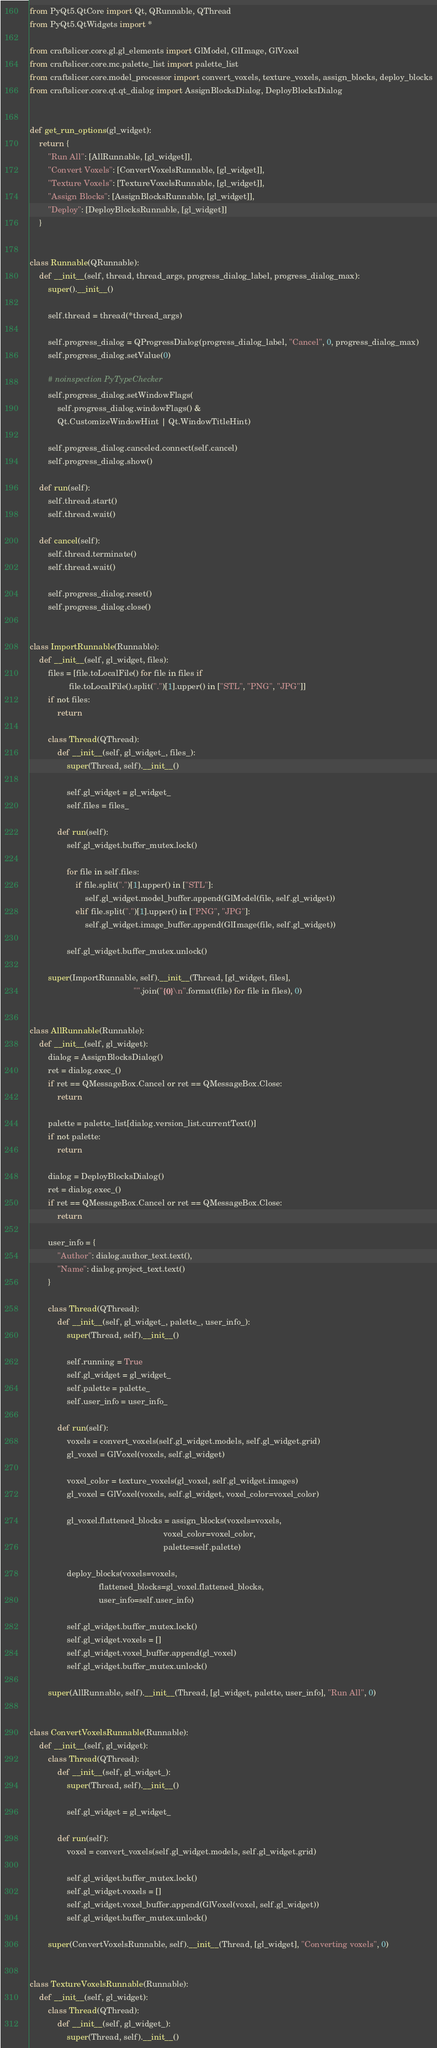<code> <loc_0><loc_0><loc_500><loc_500><_Python_>from PyQt5.QtCore import Qt, QRunnable, QThread
from PyQt5.QtWidgets import *

from craftslicer.core.gl.gl_elements import GlModel, GlImage, GlVoxel
from craftslicer.core.mc.palette_list import palette_list
from craftslicer.core.model_processor import convert_voxels, texture_voxels, assign_blocks, deploy_blocks
from craftslicer.core.qt.qt_dialog import AssignBlocksDialog, DeployBlocksDialog


def get_run_options(gl_widget):
    return {
        "Run All": [AllRunnable, [gl_widget]],
        "Convert Voxels": [ConvertVoxelsRunnable, [gl_widget]],
        "Texture Voxels": [TextureVoxelsRunnable, [gl_widget]],
        "Assign Blocks": [AssignBlocksRunnable, [gl_widget]],
        "Deploy": [DeployBlocksRunnable, [gl_widget]]
    }


class Runnable(QRunnable):
    def __init__(self, thread, thread_args, progress_dialog_label, progress_dialog_max):
        super().__init__()

        self.thread = thread(*thread_args)

        self.progress_dialog = QProgressDialog(progress_dialog_label, "Cancel", 0, progress_dialog_max)
        self.progress_dialog.setValue(0)

        # noinspection PyTypeChecker
        self.progress_dialog.setWindowFlags(
            self.progress_dialog.windowFlags() &
            Qt.CustomizeWindowHint | Qt.WindowTitleHint)

        self.progress_dialog.canceled.connect(self.cancel)
        self.progress_dialog.show()

    def run(self):
        self.thread.start()
        self.thread.wait()

    def cancel(self):
        self.thread.terminate()
        self.thread.wait()

        self.progress_dialog.reset()
        self.progress_dialog.close()


class ImportRunnable(Runnable):
    def __init__(self, gl_widget, files):
        files = [file.toLocalFile() for file in files if
                 file.toLocalFile().split(".")[1].upper() in ["STL", "PNG", "JPG"]]
        if not files:
            return

        class Thread(QThread):
            def __init__(self, gl_widget_, files_):
                super(Thread, self).__init__()

                self.gl_widget = gl_widget_
                self.files = files_

            def run(self):
                self.gl_widget.buffer_mutex.lock()

                for file in self.files:
                    if file.split(".")[1].upper() in ["STL"]:
                        self.gl_widget.model_buffer.append(GlModel(file, self.gl_widget))
                    elif file.split(".")[1].upper() in ["PNG", "JPG"]:
                        self.gl_widget.image_buffer.append(GlImage(file, self.gl_widget))

                self.gl_widget.buffer_mutex.unlock()

        super(ImportRunnable, self).__init__(Thread, [gl_widget, files],
                                             "".join("{0}\n".format(file) for file in files), 0)


class AllRunnable(Runnable):
    def __init__(self, gl_widget):
        dialog = AssignBlocksDialog()
        ret = dialog.exec_()
        if ret == QMessageBox.Cancel or ret == QMessageBox.Close:
            return

        palette = palette_list[dialog.version_list.currentText()]
        if not palette:
            return

        dialog = DeployBlocksDialog()
        ret = dialog.exec_()
        if ret == QMessageBox.Cancel or ret == QMessageBox.Close:
            return

        user_info = {
            "Author": dialog.author_text.text(),
            "Name": dialog.project_text.text()
        }

        class Thread(QThread):
            def __init__(self, gl_widget_, palette_, user_info_):
                super(Thread, self).__init__()

                self.running = True
                self.gl_widget = gl_widget_
                self.palette = palette_
                self.user_info = user_info_

            def run(self):
                voxels = convert_voxels(self.gl_widget.models, self.gl_widget.grid)
                gl_voxel = GlVoxel(voxels, self.gl_widget)

                voxel_color = texture_voxels(gl_voxel, self.gl_widget.images)
                gl_voxel = GlVoxel(voxels, self.gl_widget, voxel_color=voxel_color)

                gl_voxel.flattened_blocks = assign_blocks(voxels=voxels,
                                                          voxel_color=voxel_color,
                                                          palette=self.palette)

                deploy_blocks(voxels=voxels,
                              flattened_blocks=gl_voxel.flattened_blocks,
                              user_info=self.user_info)

                self.gl_widget.buffer_mutex.lock()
                self.gl_widget.voxels = []
                self.gl_widget.voxel_buffer.append(gl_voxel)
                self.gl_widget.buffer_mutex.unlock()

        super(AllRunnable, self).__init__(Thread, [gl_widget, palette, user_info], "Run All", 0)


class ConvertVoxelsRunnable(Runnable):
    def __init__(self, gl_widget):
        class Thread(QThread):
            def __init__(self, gl_widget_):
                super(Thread, self).__init__()

                self.gl_widget = gl_widget_

            def run(self):
                voxel = convert_voxels(self.gl_widget.models, self.gl_widget.grid)

                self.gl_widget.buffer_mutex.lock()
                self.gl_widget.voxels = []
                self.gl_widget.voxel_buffer.append(GlVoxel(voxel, self.gl_widget))
                self.gl_widget.buffer_mutex.unlock()

        super(ConvertVoxelsRunnable, self).__init__(Thread, [gl_widget], "Converting voxels", 0)


class TextureVoxelsRunnable(Runnable):
    def __init__(self, gl_widget):
        class Thread(QThread):
            def __init__(self, gl_widget_):
                super(Thread, self).__init__()
</code> 